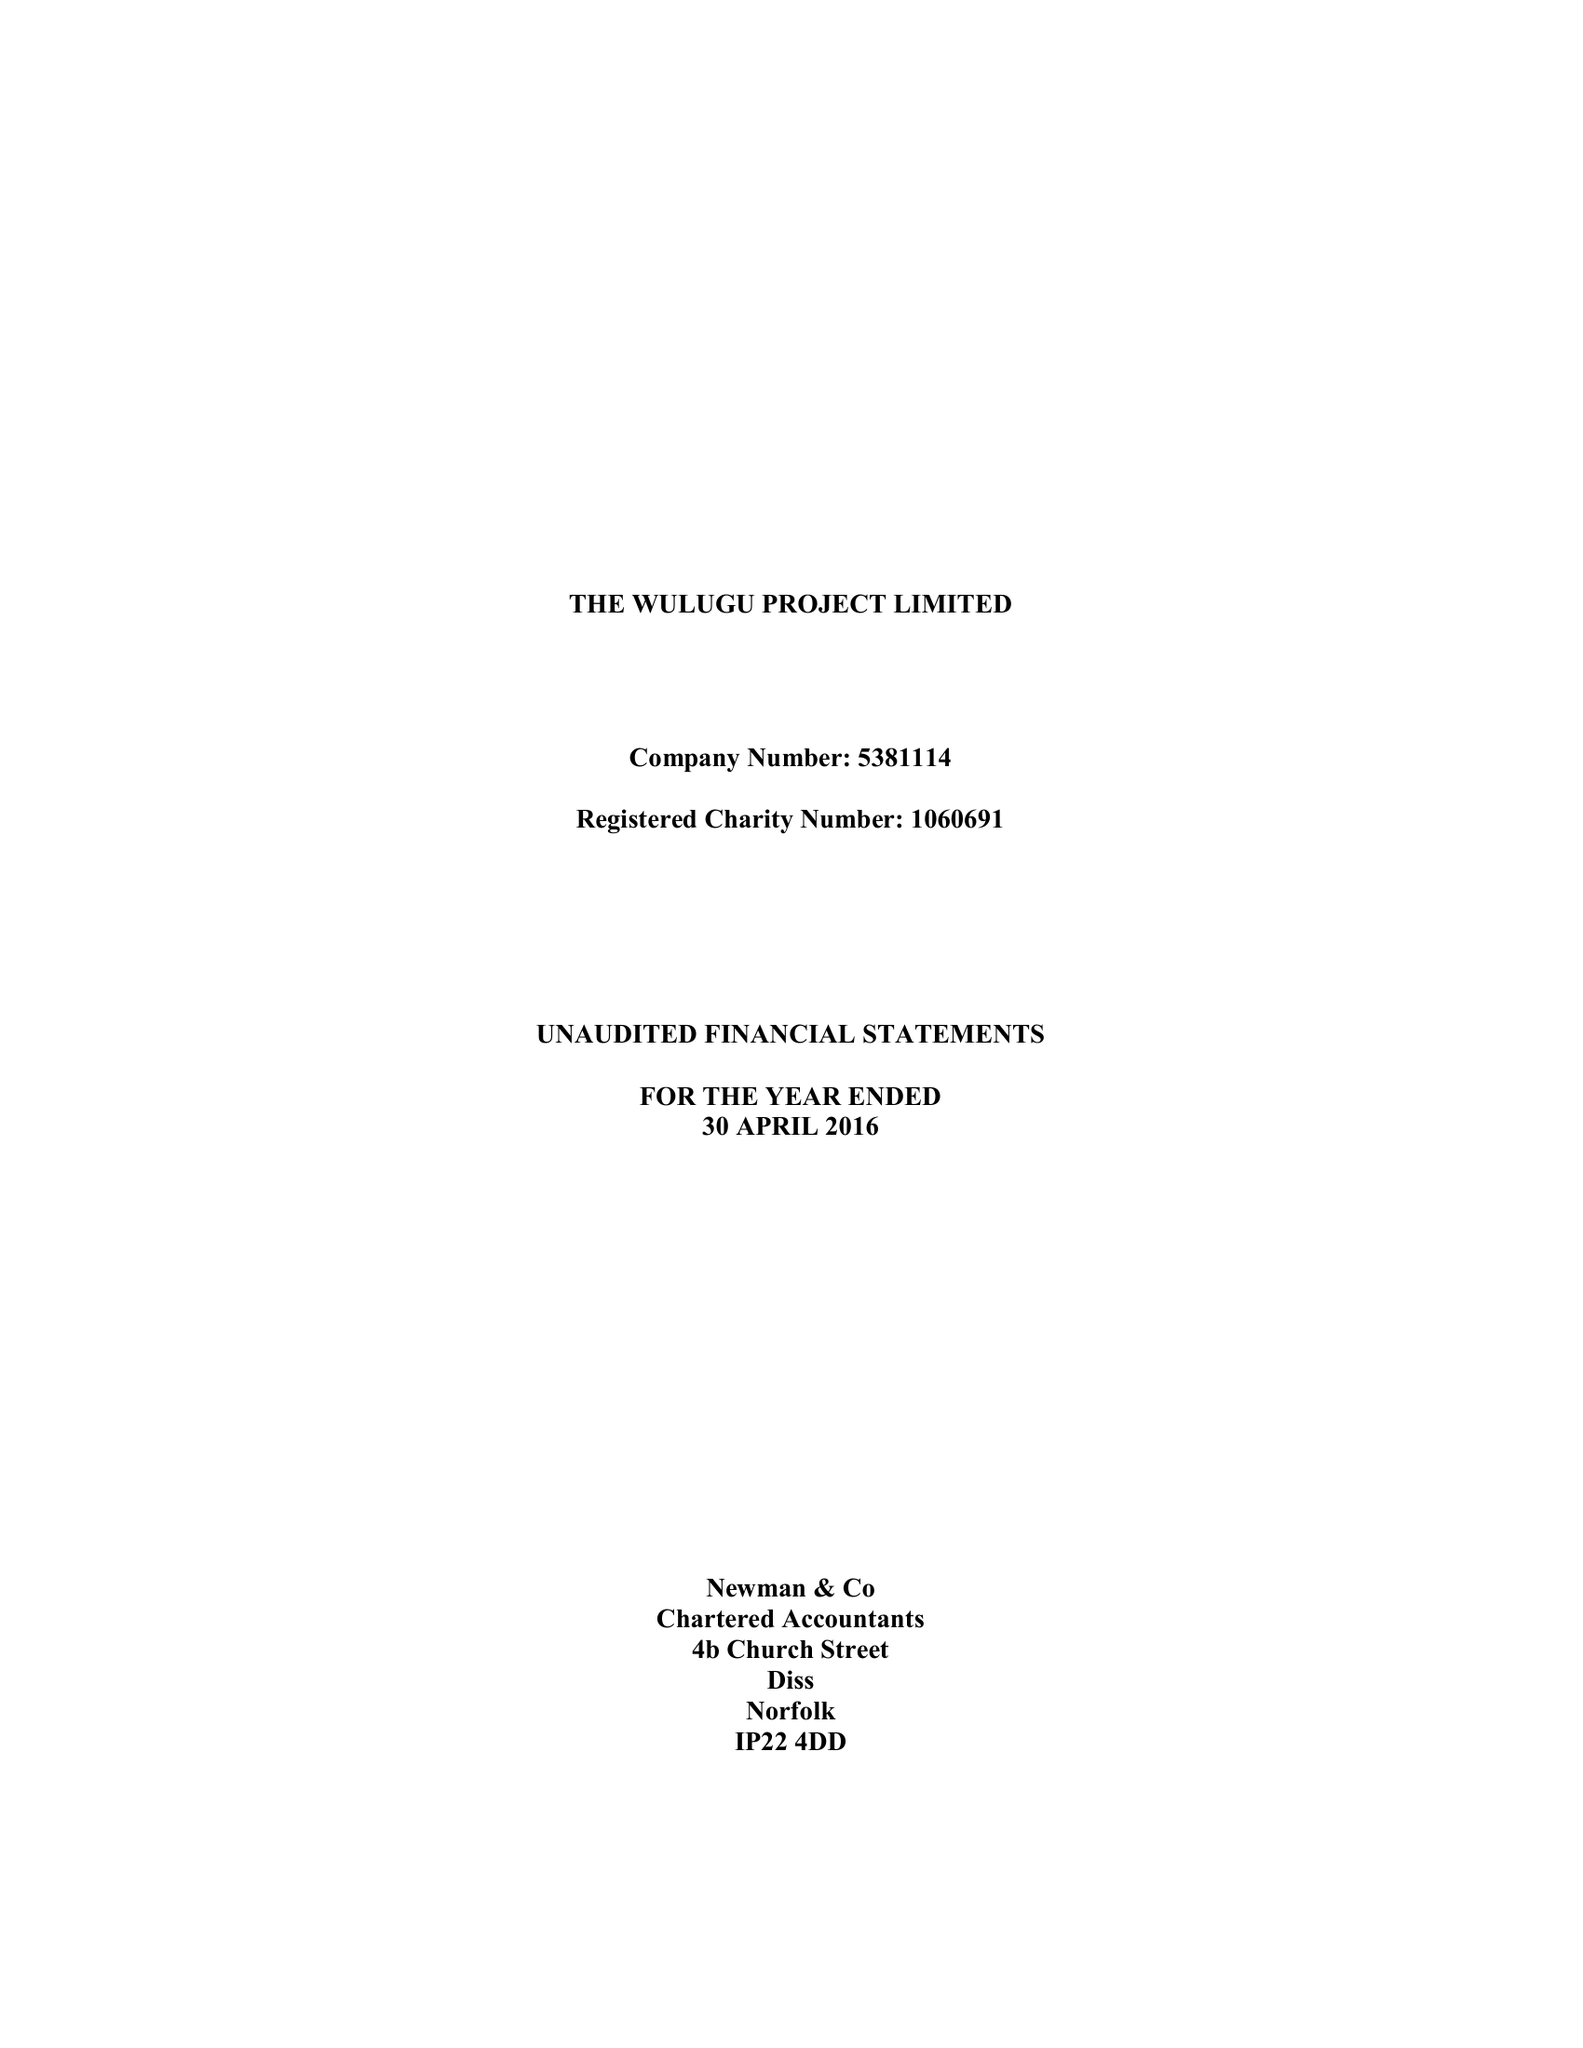What is the value for the address__street_line?
Answer the question using a single word or phrase. CHURCH FARM 